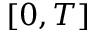<formula> <loc_0><loc_0><loc_500><loc_500>[ 0 , T ]</formula> 